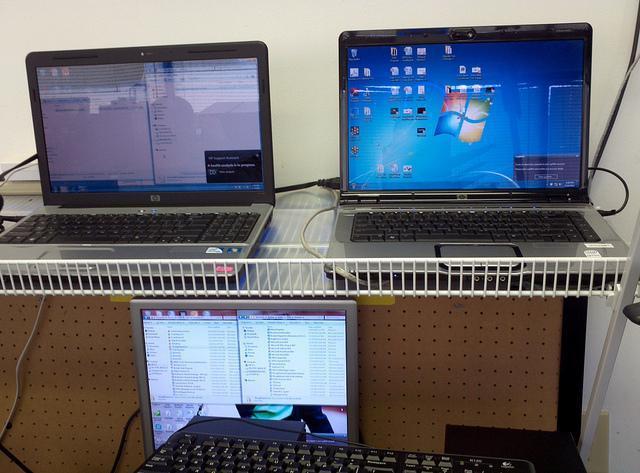How many screens do you see?
Give a very brief answer. 3. How many laptops are in the picture?
Give a very brief answer. 2. How many keyboards are in the photo?
Give a very brief answer. 3. How many people are looking at the white car?
Give a very brief answer. 0. 